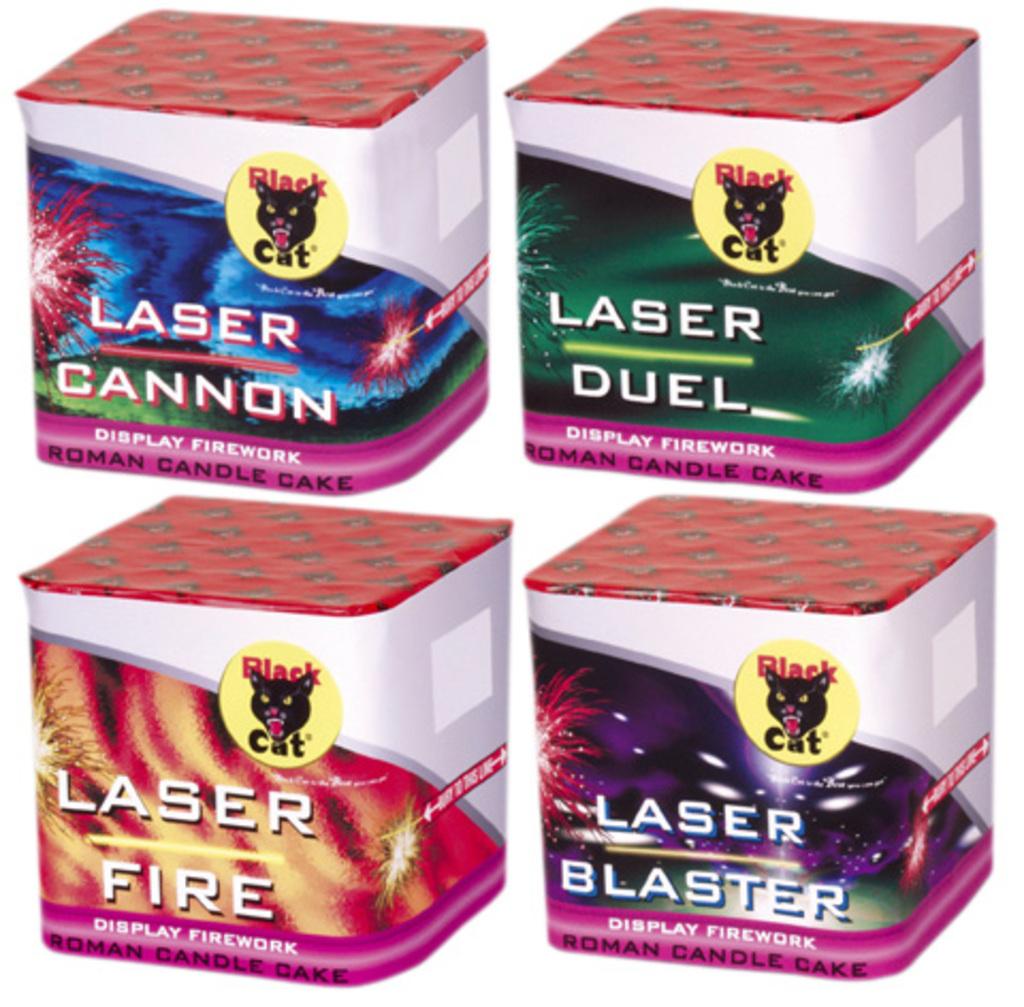Who makes the lasers?
Keep it short and to the point. Black cat. What are the differences between the lasers?
Keep it short and to the point. Cannon, duel, fire, blaster. 